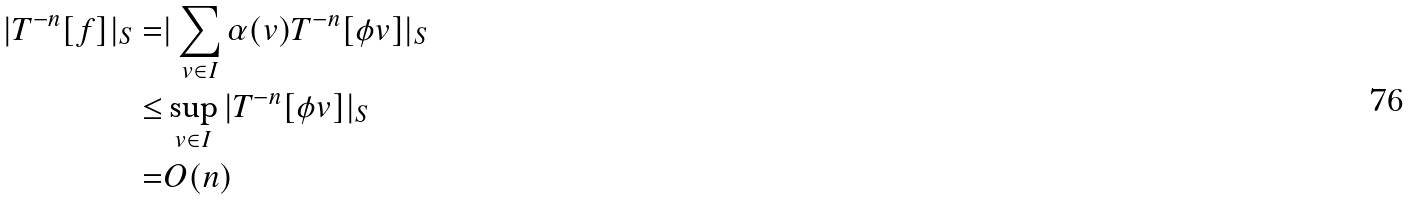Convert formula to latex. <formula><loc_0><loc_0><loc_500><loc_500>| T ^ { - n } [ f ] | _ { S } = & | \sum _ { v \in I } \alpha ( v ) T ^ { - n } [ \phi v ] | _ { S } \\ \leq & \sup _ { v \in I } | T ^ { - n } [ \phi v ] | _ { S } \\ = & O ( n )</formula> 